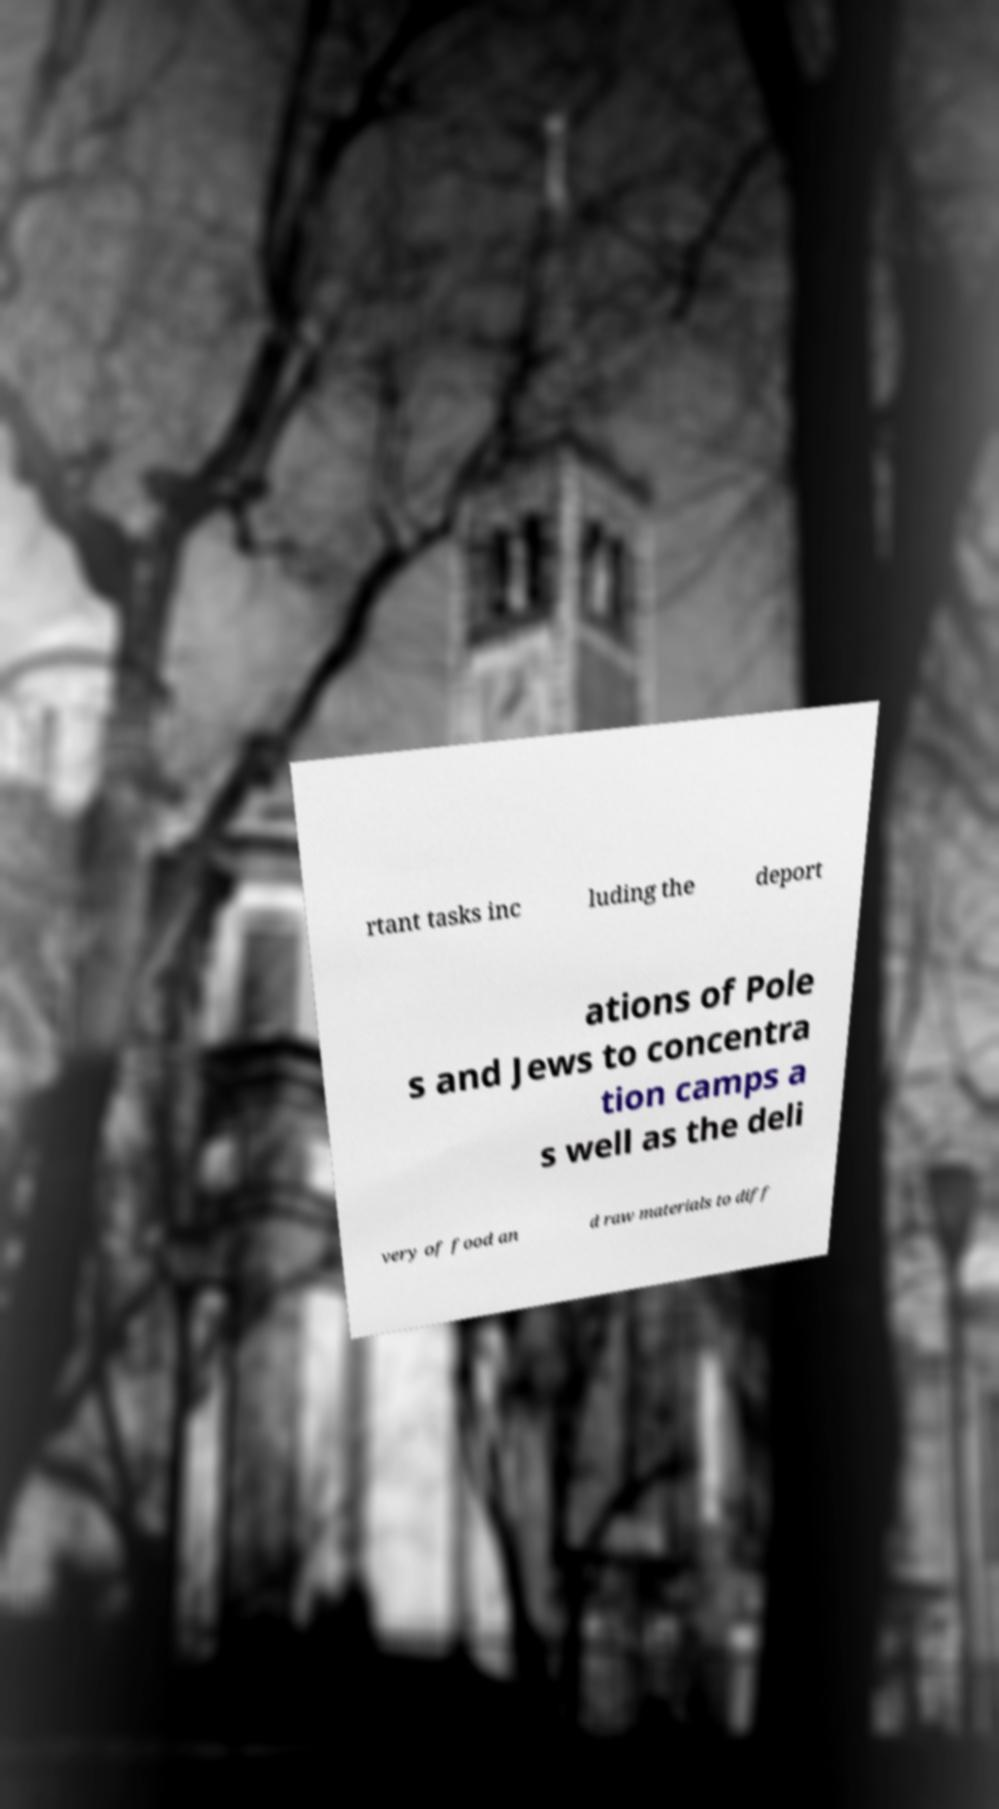What messages or text are displayed in this image? I need them in a readable, typed format. rtant tasks inc luding the deport ations of Pole s and Jews to concentra tion camps a s well as the deli very of food an d raw materials to diff 